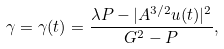Convert formula to latex. <formula><loc_0><loc_0><loc_500><loc_500>\gamma = \gamma ( t ) = \frac { \lambda P - | A ^ { 3 / 2 } u ( t ) | ^ { 2 } } { G ^ { 2 } - P } ,</formula> 